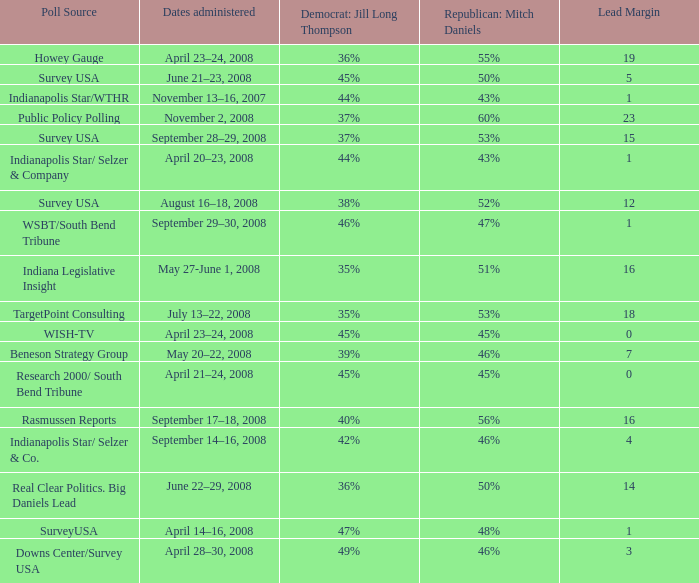What is the lowest Lead Margin when Republican: Mitch Daniels was polling at 48%? 1.0. Parse the full table. {'header': ['Poll Source', 'Dates administered', 'Democrat: Jill Long Thompson', 'Republican: Mitch Daniels', 'Lead Margin'], 'rows': [['Howey Gauge', 'April 23–24, 2008', '36%', '55%', '19'], ['Survey USA', 'June 21–23, 2008', '45%', '50%', '5'], ['Indianapolis Star/WTHR', 'November 13–16, 2007', '44%', '43%', '1'], ['Public Policy Polling', 'November 2, 2008', '37%', '60%', '23'], ['Survey USA', 'September 28–29, 2008', '37%', '53%', '15'], ['Indianapolis Star/ Selzer & Company', 'April 20–23, 2008', '44%', '43%', '1'], ['Survey USA', 'August 16–18, 2008', '38%', '52%', '12'], ['WSBT/South Bend Tribune', 'September 29–30, 2008', '46%', '47%', '1'], ['Indiana Legislative Insight', 'May 27-June 1, 2008', '35%', '51%', '16'], ['TargetPoint Consulting', 'July 13–22, 2008', '35%', '53%', '18'], ['WISH-TV', 'April 23–24, 2008', '45%', '45%', '0'], ['Beneson Strategy Group', 'May 20–22, 2008', '39%', '46%', '7'], ['Research 2000/ South Bend Tribune', 'April 21–24, 2008', '45%', '45%', '0'], ['Rasmussen Reports', 'September 17–18, 2008', '40%', '56%', '16'], ['Indianapolis Star/ Selzer & Co.', 'September 14–16, 2008', '42%', '46%', '4'], ['Real Clear Politics. Big Daniels Lead', 'June 22–29, 2008', '36%', '50%', '14'], ['SurveyUSA', 'April 14–16, 2008', '47%', '48%', '1'], ['Downs Center/Survey USA', 'April 28–30, 2008', '49%', '46%', '3']]} 